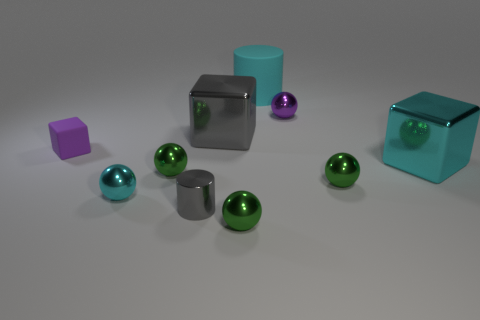There is a green object right of the large cylinder; is its shape the same as the purple thing that is right of the small cyan sphere?
Your answer should be compact. Yes. Are the large cube that is behind the matte cube and the small cube made of the same material?
Your response must be concise. No. There is a big thing that is in front of the cyan cylinder and on the left side of the purple metallic object; what material is it?
Your answer should be compact. Metal. The purple metallic object is what size?
Your response must be concise. Small. There is a block to the right of the purple metallic sphere; what size is it?
Your answer should be very brief. Large. What is the shape of the cyan object that is in front of the cyan rubber cylinder and behind the cyan shiny sphere?
Give a very brief answer. Cube. How many other things are there of the same shape as the purple metal thing?
Ensure brevity in your answer.  4. What is the color of the metal cylinder that is the same size as the purple rubber block?
Offer a terse response. Gray. What number of things are large yellow metallic balls or gray blocks?
Ensure brevity in your answer.  1. There is a gray metallic block; are there any matte things to the left of it?
Give a very brief answer. Yes. 